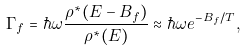<formula> <loc_0><loc_0><loc_500><loc_500>\Gamma _ { f } = \hbar { \omega } \frac { \rho ^ { * } ( E - B _ { f } ) } { \rho ^ { * } ( E ) } \approx \hbar { \omega } e ^ { - B _ { f } / T } ,</formula> 